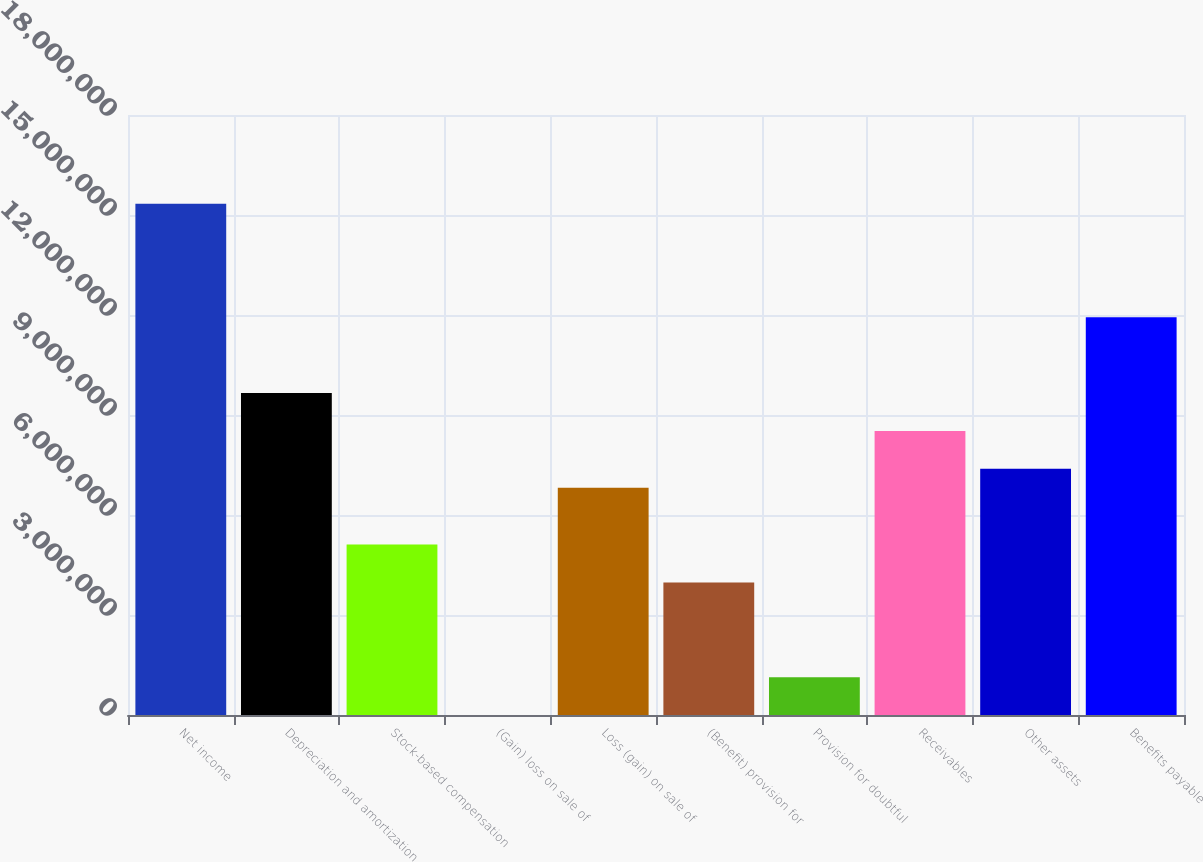Convert chart to OTSL. <chart><loc_0><loc_0><loc_500><loc_500><bar_chart><fcel>Net income<fcel>Depreciation and amortization<fcel>Stock-based compensation<fcel>(Gain) loss on sale of<fcel>Loss (gain) on sale of<fcel>(Benefit) provision for<fcel>Provision for doubtful<fcel>Receivables<fcel>Other assets<fcel>Benefits payable<nl><fcel>1.5339e+07<fcel>9.65787e+06<fcel>5.11299e+06<fcel>5<fcel>6.81732e+06<fcel>3.97677e+06<fcel>1.13622e+06<fcel>8.52165e+06<fcel>7.38543e+06<fcel>1.19303e+07<nl></chart> 